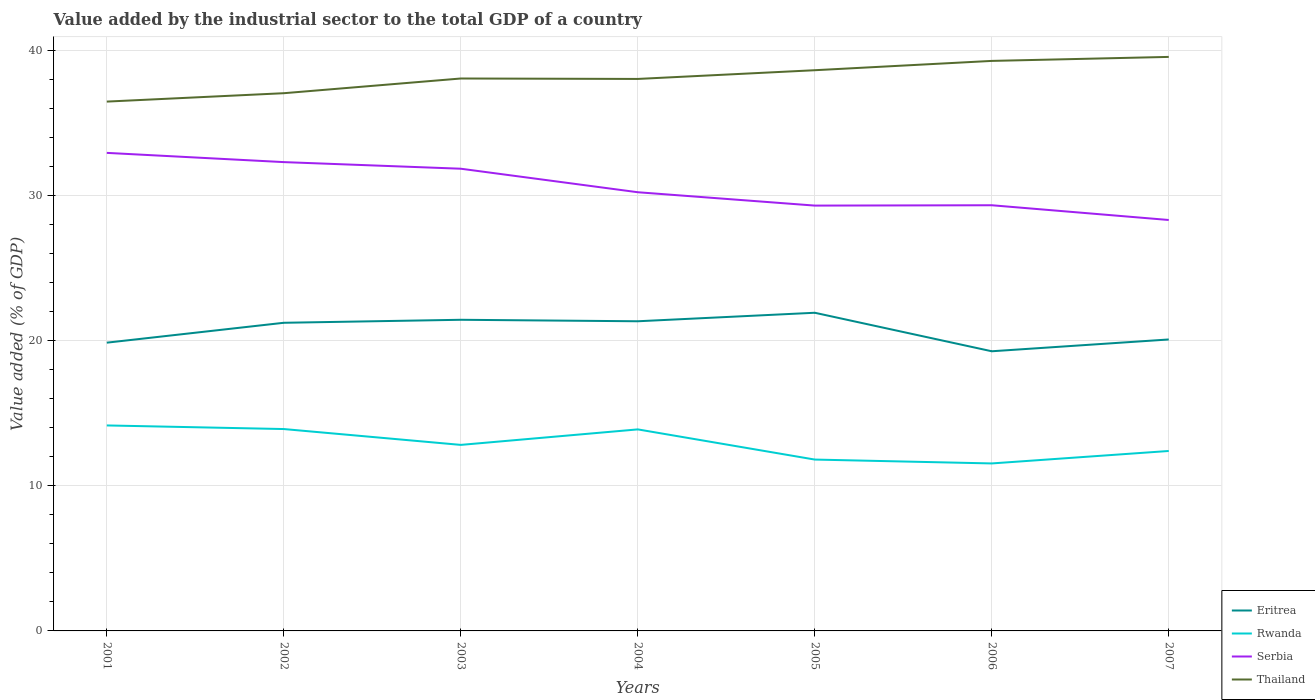Is the number of lines equal to the number of legend labels?
Offer a very short reply. Yes. Across all years, what is the maximum value added by the industrial sector to the total GDP in Eritrea?
Offer a terse response. 19.27. In which year was the value added by the industrial sector to the total GDP in Thailand maximum?
Ensure brevity in your answer.  2001. What is the total value added by the industrial sector to the total GDP in Thailand in the graph?
Your response must be concise. 0.03. What is the difference between the highest and the second highest value added by the industrial sector to the total GDP in Rwanda?
Keep it short and to the point. 2.62. What is the difference between the highest and the lowest value added by the industrial sector to the total GDP in Serbia?
Provide a succinct answer. 3. How many lines are there?
Provide a short and direct response. 4. Are the values on the major ticks of Y-axis written in scientific E-notation?
Your response must be concise. No. Does the graph contain any zero values?
Your answer should be compact. No. Where does the legend appear in the graph?
Your answer should be compact. Bottom right. How are the legend labels stacked?
Your answer should be very brief. Vertical. What is the title of the graph?
Provide a succinct answer. Value added by the industrial sector to the total GDP of a country. Does "Pakistan" appear as one of the legend labels in the graph?
Provide a short and direct response. No. What is the label or title of the X-axis?
Offer a terse response. Years. What is the label or title of the Y-axis?
Give a very brief answer. Value added (% of GDP). What is the Value added (% of GDP) of Eritrea in 2001?
Make the answer very short. 19.86. What is the Value added (% of GDP) of Rwanda in 2001?
Offer a terse response. 14.16. What is the Value added (% of GDP) of Serbia in 2001?
Provide a succinct answer. 32.93. What is the Value added (% of GDP) in Thailand in 2001?
Your answer should be compact. 36.47. What is the Value added (% of GDP) in Eritrea in 2002?
Keep it short and to the point. 21.23. What is the Value added (% of GDP) in Rwanda in 2002?
Offer a very short reply. 13.91. What is the Value added (% of GDP) of Serbia in 2002?
Offer a terse response. 32.3. What is the Value added (% of GDP) of Thailand in 2002?
Your response must be concise. 37.04. What is the Value added (% of GDP) in Eritrea in 2003?
Provide a succinct answer. 21.44. What is the Value added (% of GDP) of Rwanda in 2003?
Ensure brevity in your answer.  12.82. What is the Value added (% of GDP) in Serbia in 2003?
Keep it short and to the point. 31.84. What is the Value added (% of GDP) in Thailand in 2003?
Offer a terse response. 38.06. What is the Value added (% of GDP) in Eritrea in 2004?
Your answer should be compact. 21.33. What is the Value added (% of GDP) of Rwanda in 2004?
Provide a short and direct response. 13.88. What is the Value added (% of GDP) in Serbia in 2004?
Offer a very short reply. 30.22. What is the Value added (% of GDP) of Thailand in 2004?
Offer a very short reply. 38.03. What is the Value added (% of GDP) in Eritrea in 2005?
Make the answer very short. 21.92. What is the Value added (% of GDP) in Rwanda in 2005?
Make the answer very short. 11.81. What is the Value added (% of GDP) of Serbia in 2005?
Your answer should be compact. 29.3. What is the Value added (% of GDP) in Thailand in 2005?
Ensure brevity in your answer.  38.63. What is the Value added (% of GDP) of Eritrea in 2006?
Make the answer very short. 19.27. What is the Value added (% of GDP) of Rwanda in 2006?
Keep it short and to the point. 11.54. What is the Value added (% of GDP) of Serbia in 2006?
Your answer should be very brief. 29.33. What is the Value added (% of GDP) of Thailand in 2006?
Provide a succinct answer. 39.27. What is the Value added (% of GDP) in Eritrea in 2007?
Keep it short and to the point. 20.08. What is the Value added (% of GDP) of Rwanda in 2007?
Keep it short and to the point. 12.4. What is the Value added (% of GDP) in Serbia in 2007?
Make the answer very short. 28.31. What is the Value added (% of GDP) in Thailand in 2007?
Your answer should be compact. 39.55. Across all years, what is the maximum Value added (% of GDP) in Eritrea?
Keep it short and to the point. 21.92. Across all years, what is the maximum Value added (% of GDP) in Rwanda?
Your answer should be very brief. 14.16. Across all years, what is the maximum Value added (% of GDP) in Serbia?
Your response must be concise. 32.93. Across all years, what is the maximum Value added (% of GDP) of Thailand?
Ensure brevity in your answer.  39.55. Across all years, what is the minimum Value added (% of GDP) in Eritrea?
Your answer should be compact. 19.27. Across all years, what is the minimum Value added (% of GDP) in Rwanda?
Offer a very short reply. 11.54. Across all years, what is the minimum Value added (% of GDP) of Serbia?
Ensure brevity in your answer.  28.31. Across all years, what is the minimum Value added (% of GDP) in Thailand?
Offer a terse response. 36.47. What is the total Value added (% of GDP) of Eritrea in the graph?
Make the answer very short. 145.12. What is the total Value added (% of GDP) of Rwanda in the graph?
Provide a succinct answer. 90.51. What is the total Value added (% of GDP) in Serbia in the graph?
Give a very brief answer. 214.24. What is the total Value added (% of GDP) of Thailand in the graph?
Your answer should be compact. 267.04. What is the difference between the Value added (% of GDP) of Eritrea in 2001 and that in 2002?
Offer a terse response. -1.37. What is the difference between the Value added (% of GDP) in Rwanda in 2001 and that in 2002?
Ensure brevity in your answer.  0.25. What is the difference between the Value added (% of GDP) of Serbia in 2001 and that in 2002?
Your response must be concise. 0.64. What is the difference between the Value added (% of GDP) in Thailand in 2001 and that in 2002?
Your response must be concise. -0.58. What is the difference between the Value added (% of GDP) of Eritrea in 2001 and that in 2003?
Your answer should be compact. -1.58. What is the difference between the Value added (% of GDP) of Rwanda in 2001 and that in 2003?
Provide a succinct answer. 1.34. What is the difference between the Value added (% of GDP) in Serbia in 2001 and that in 2003?
Your answer should be compact. 1.09. What is the difference between the Value added (% of GDP) of Thailand in 2001 and that in 2003?
Your response must be concise. -1.59. What is the difference between the Value added (% of GDP) in Eritrea in 2001 and that in 2004?
Give a very brief answer. -1.47. What is the difference between the Value added (% of GDP) of Rwanda in 2001 and that in 2004?
Make the answer very short. 0.27. What is the difference between the Value added (% of GDP) in Serbia in 2001 and that in 2004?
Offer a very short reply. 2.71. What is the difference between the Value added (% of GDP) in Thailand in 2001 and that in 2004?
Your answer should be very brief. -1.56. What is the difference between the Value added (% of GDP) of Eritrea in 2001 and that in 2005?
Your answer should be very brief. -2.06. What is the difference between the Value added (% of GDP) in Rwanda in 2001 and that in 2005?
Offer a terse response. 2.35. What is the difference between the Value added (% of GDP) in Serbia in 2001 and that in 2005?
Provide a succinct answer. 3.63. What is the difference between the Value added (% of GDP) of Thailand in 2001 and that in 2005?
Give a very brief answer. -2.16. What is the difference between the Value added (% of GDP) of Eritrea in 2001 and that in 2006?
Provide a short and direct response. 0.59. What is the difference between the Value added (% of GDP) in Rwanda in 2001 and that in 2006?
Your answer should be compact. 2.62. What is the difference between the Value added (% of GDP) of Serbia in 2001 and that in 2006?
Keep it short and to the point. 3.61. What is the difference between the Value added (% of GDP) in Thailand in 2001 and that in 2006?
Offer a very short reply. -2.8. What is the difference between the Value added (% of GDP) in Eritrea in 2001 and that in 2007?
Your answer should be compact. -0.22. What is the difference between the Value added (% of GDP) of Rwanda in 2001 and that in 2007?
Your response must be concise. 1.76. What is the difference between the Value added (% of GDP) in Serbia in 2001 and that in 2007?
Your answer should be compact. 4.62. What is the difference between the Value added (% of GDP) of Thailand in 2001 and that in 2007?
Give a very brief answer. -3.08. What is the difference between the Value added (% of GDP) in Eritrea in 2002 and that in 2003?
Your answer should be compact. -0.21. What is the difference between the Value added (% of GDP) in Rwanda in 2002 and that in 2003?
Your answer should be compact. 1.09. What is the difference between the Value added (% of GDP) in Serbia in 2002 and that in 2003?
Offer a very short reply. 0.46. What is the difference between the Value added (% of GDP) of Thailand in 2002 and that in 2003?
Your answer should be compact. -1.01. What is the difference between the Value added (% of GDP) in Eritrea in 2002 and that in 2004?
Offer a terse response. -0.1. What is the difference between the Value added (% of GDP) in Rwanda in 2002 and that in 2004?
Provide a succinct answer. 0.02. What is the difference between the Value added (% of GDP) of Serbia in 2002 and that in 2004?
Your response must be concise. 2.08. What is the difference between the Value added (% of GDP) in Thailand in 2002 and that in 2004?
Provide a succinct answer. -0.98. What is the difference between the Value added (% of GDP) in Eritrea in 2002 and that in 2005?
Offer a very short reply. -0.69. What is the difference between the Value added (% of GDP) of Rwanda in 2002 and that in 2005?
Your answer should be compact. 2.1. What is the difference between the Value added (% of GDP) of Serbia in 2002 and that in 2005?
Offer a very short reply. 3. What is the difference between the Value added (% of GDP) of Thailand in 2002 and that in 2005?
Your answer should be very brief. -1.58. What is the difference between the Value added (% of GDP) in Eritrea in 2002 and that in 2006?
Offer a terse response. 1.96. What is the difference between the Value added (% of GDP) of Rwanda in 2002 and that in 2006?
Provide a short and direct response. 2.37. What is the difference between the Value added (% of GDP) in Serbia in 2002 and that in 2006?
Make the answer very short. 2.97. What is the difference between the Value added (% of GDP) in Thailand in 2002 and that in 2006?
Provide a short and direct response. -2.23. What is the difference between the Value added (% of GDP) in Eritrea in 2002 and that in 2007?
Offer a very short reply. 1.15. What is the difference between the Value added (% of GDP) in Rwanda in 2002 and that in 2007?
Your response must be concise. 1.51. What is the difference between the Value added (% of GDP) of Serbia in 2002 and that in 2007?
Provide a succinct answer. 3.99. What is the difference between the Value added (% of GDP) in Thailand in 2002 and that in 2007?
Keep it short and to the point. -2.5. What is the difference between the Value added (% of GDP) in Eritrea in 2003 and that in 2004?
Provide a succinct answer. 0.1. What is the difference between the Value added (% of GDP) of Rwanda in 2003 and that in 2004?
Give a very brief answer. -1.07. What is the difference between the Value added (% of GDP) of Serbia in 2003 and that in 2004?
Offer a very short reply. 1.62. What is the difference between the Value added (% of GDP) of Thailand in 2003 and that in 2004?
Offer a terse response. 0.03. What is the difference between the Value added (% of GDP) of Eritrea in 2003 and that in 2005?
Provide a succinct answer. -0.48. What is the difference between the Value added (% of GDP) in Rwanda in 2003 and that in 2005?
Offer a very short reply. 1.01. What is the difference between the Value added (% of GDP) in Serbia in 2003 and that in 2005?
Provide a short and direct response. 2.54. What is the difference between the Value added (% of GDP) of Thailand in 2003 and that in 2005?
Offer a very short reply. -0.57. What is the difference between the Value added (% of GDP) in Eritrea in 2003 and that in 2006?
Provide a short and direct response. 2.17. What is the difference between the Value added (% of GDP) of Rwanda in 2003 and that in 2006?
Provide a short and direct response. 1.28. What is the difference between the Value added (% of GDP) in Serbia in 2003 and that in 2006?
Your response must be concise. 2.52. What is the difference between the Value added (% of GDP) in Thailand in 2003 and that in 2006?
Ensure brevity in your answer.  -1.21. What is the difference between the Value added (% of GDP) of Eritrea in 2003 and that in 2007?
Offer a very short reply. 1.36. What is the difference between the Value added (% of GDP) of Rwanda in 2003 and that in 2007?
Offer a terse response. 0.42. What is the difference between the Value added (% of GDP) of Serbia in 2003 and that in 2007?
Your answer should be very brief. 3.53. What is the difference between the Value added (% of GDP) of Thailand in 2003 and that in 2007?
Ensure brevity in your answer.  -1.49. What is the difference between the Value added (% of GDP) in Eritrea in 2004 and that in 2005?
Give a very brief answer. -0.59. What is the difference between the Value added (% of GDP) of Rwanda in 2004 and that in 2005?
Your answer should be very brief. 2.08. What is the difference between the Value added (% of GDP) of Serbia in 2004 and that in 2005?
Your response must be concise. 0.92. What is the difference between the Value added (% of GDP) in Thailand in 2004 and that in 2005?
Make the answer very short. -0.6. What is the difference between the Value added (% of GDP) in Eritrea in 2004 and that in 2006?
Your response must be concise. 2.07. What is the difference between the Value added (% of GDP) in Rwanda in 2004 and that in 2006?
Keep it short and to the point. 2.35. What is the difference between the Value added (% of GDP) of Serbia in 2004 and that in 2006?
Your answer should be very brief. 0.9. What is the difference between the Value added (% of GDP) of Thailand in 2004 and that in 2006?
Give a very brief answer. -1.24. What is the difference between the Value added (% of GDP) of Eritrea in 2004 and that in 2007?
Make the answer very short. 1.25. What is the difference between the Value added (% of GDP) of Rwanda in 2004 and that in 2007?
Your response must be concise. 1.49. What is the difference between the Value added (% of GDP) of Serbia in 2004 and that in 2007?
Provide a succinct answer. 1.91. What is the difference between the Value added (% of GDP) of Thailand in 2004 and that in 2007?
Keep it short and to the point. -1.52. What is the difference between the Value added (% of GDP) of Eritrea in 2005 and that in 2006?
Offer a very short reply. 2.65. What is the difference between the Value added (% of GDP) in Rwanda in 2005 and that in 2006?
Your answer should be very brief. 0.27. What is the difference between the Value added (% of GDP) in Serbia in 2005 and that in 2006?
Offer a terse response. -0.02. What is the difference between the Value added (% of GDP) in Thailand in 2005 and that in 2006?
Give a very brief answer. -0.64. What is the difference between the Value added (% of GDP) in Eritrea in 2005 and that in 2007?
Give a very brief answer. 1.84. What is the difference between the Value added (% of GDP) in Rwanda in 2005 and that in 2007?
Offer a terse response. -0.59. What is the difference between the Value added (% of GDP) of Serbia in 2005 and that in 2007?
Offer a very short reply. 0.99. What is the difference between the Value added (% of GDP) of Thailand in 2005 and that in 2007?
Ensure brevity in your answer.  -0.92. What is the difference between the Value added (% of GDP) of Eritrea in 2006 and that in 2007?
Ensure brevity in your answer.  -0.81. What is the difference between the Value added (% of GDP) of Rwanda in 2006 and that in 2007?
Your answer should be very brief. -0.86. What is the difference between the Value added (% of GDP) of Serbia in 2006 and that in 2007?
Ensure brevity in your answer.  1.02. What is the difference between the Value added (% of GDP) in Thailand in 2006 and that in 2007?
Your response must be concise. -0.28. What is the difference between the Value added (% of GDP) of Eritrea in 2001 and the Value added (% of GDP) of Rwanda in 2002?
Offer a very short reply. 5.95. What is the difference between the Value added (% of GDP) in Eritrea in 2001 and the Value added (% of GDP) in Serbia in 2002?
Your response must be concise. -12.44. What is the difference between the Value added (% of GDP) in Eritrea in 2001 and the Value added (% of GDP) in Thailand in 2002?
Offer a very short reply. -17.19. What is the difference between the Value added (% of GDP) in Rwanda in 2001 and the Value added (% of GDP) in Serbia in 2002?
Give a very brief answer. -18.14. What is the difference between the Value added (% of GDP) in Rwanda in 2001 and the Value added (% of GDP) in Thailand in 2002?
Offer a very short reply. -22.89. What is the difference between the Value added (% of GDP) in Serbia in 2001 and the Value added (% of GDP) in Thailand in 2002?
Your answer should be very brief. -4.11. What is the difference between the Value added (% of GDP) of Eritrea in 2001 and the Value added (% of GDP) of Rwanda in 2003?
Your answer should be very brief. 7.04. What is the difference between the Value added (% of GDP) of Eritrea in 2001 and the Value added (% of GDP) of Serbia in 2003?
Your answer should be very brief. -11.98. What is the difference between the Value added (% of GDP) in Eritrea in 2001 and the Value added (% of GDP) in Thailand in 2003?
Keep it short and to the point. -18.2. What is the difference between the Value added (% of GDP) of Rwanda in 2001 and the Value added (% of GDP) of Serbia in 2003?
Offer a very short reply. -17.69. What is the difference between the Value added (% of GDP) of Rwanda in 2001 and the Value added (% of GDP) of Thailand in 2003?
Provide a succinct answer. -23.9. What is the difference between the Value added (% of GDP) in Serbia in 2001 and the Value added (% of GDP) in Thailand in 2003?
Your response must be concise. -5.12. What is the difference between the Value added (% of GDP) in Eritrea in 2001 and the Value added (% of GDP) in Rwanda in 2004?
Your answer should be very brief. 5.98. What is the difference between the Value added (% of GDP) of Eritrea in 2001 and the Value added (% of GDP) of Serbia in 2004?
Ensure brevity in your answer.  -10.36. What is the difference between the Value added (% of GDP) of Eritrea in 2001 and the Value added (% of GDP) of Thailand in 2004?
Your response must be concise. -18.17. What is the difference between the Value added (% of GDP) of Rwanda in 2001 and the Value added (% of GDP) of Serbia in 2004?
Your response must be concise. -16.07. What is the difference between the Value added (% of GDP) in Rwanda in 2001 and the Value added (% of GDP) in Thailand in 2004?
Offer a very short reply. -23.87. What is the difference between the Value added (% of GDP) of Serbia in 2001 and the Value added (% of GDP) of Thailand in 2004?
Your answer should be very brief. -5.09. What is the difference between the Value added (% of GDP) in Eritrea in 2001 and the Value added (% of GDP) in Rwanda in 2005?
Offer a very short reply. 8.05. What is the difference between the Value added (% of GDP) of Eritrea in 2001 and the Value added (% of GDP) of Serbia in 2005?
Provide a short and direct response. -9.44. What is the difference between the Value added (% of GDP) in Eritrea in 2001 and the Value added (% of GDP) in Thailand in 2005?
Provide a short and direct response. -18.77. What is the difference between the Value added (% of GDP) of Rwanda in 2001 and the Value added (% of GDP) of Serbia in 2005?
Provide a short and direct response. -15.15. What is the difference between the Value added (% of GDP) in Rwanda in 2001 and the Value added (% of GDP) in Thailand in 2005?
Provide a succinct answer. -24.47. What is the difference between the Value added (% of GDP) of Serbia in 2001 and the Value added (% of GDP) of Thailand in 2005?
Your answer should be very brief. -5.69. What is the difference between the Value added (% of GDP) in Eritrea in 2001 and the Value added (% of GDP) in Rwanda in 2006?
Make the answer very short. 8.32. What is the difference between the Value added (% of GDP) of Eritrea in 2001 and the Value added (% of GDP) of Serbia in 2006?
Provide a succinct answer. -9.47. What is the difference between the Value added (% of GDP) in Eritrea in 2001 and the Value added (% of GDP) in Thailand in 2006?
Provide a succinct answer. -19.41. What is the difference between the Value added (% of GDP) in Rwanda in 2001 and the Value added (% of GDP) in Serbia in 2006?
Make the answer very short. -15.17. What is the difference between the Value added (% of GDP) of Rwanda in 2001 and the Value added (% of GDP) of Thailand in 2006?
Provide a succinct answer. -25.11. What is the difference between the Value added (% of GDP) of Serbia in 2001 and the Value added (% of GDP) of Thailand in 2006?
Give a very brief answer. -6.34. What is the difference between the Value added (% of GDP) in Eritrea in 2001 and the Value added (% of GDP) in Rwanda in 2007?
Provide a succinct answer. 7.46. What is the difference between the Value added (% of GDP) of Eritrea in 2001 and the Value added (% of GDP) of Serbia in 2007?
Make the answer very short. -8.45. What is the difference between the Value added (% of GDP) of Eritrea in 2001 and the Value added (% of GDP) of Thailand in 2007?
Keep it short and to the point. -19.69. What is the difference between the Value added (% of GDP) of Rwanda in 2001 and the Value added (% of GDP) of Serbia in 2007?
Your answer should be very brief. -14.15. What is the difference between the Value added (% of GDP) of Rwanda in 2001 and the Value added (% of GDP) of Thailand in 2007?
Offer a very short reply. -25.39. What is the difference between the Value added (% of GDP) in Serbia in 2001 and the Value added (% of GDP) in Thailand in 2007?
Give a very brief answer. -6.61. What is the difference between the Value added (% of GDP) in Eritrea in 2002 and the Value added (% of GDP) in Rwanda in 2003?
Provide a short and direct response. 8.41. What is the difference between the Value added (% of GDP) in Eritrea in 2002 and the Value added (% of GDP) in Serbia in 2003?
Offer a very short reply. -10.61. What is the difference between the Value added (% of GDP) in Eritrea in 2002 and the Value added (% of GDP) in Thailand in 2003?
Make the answer very short. -16.83. What is the difference between the Value added (% of GDP) of Rwanda in 2002 and the Value added (% of GDP) of Serbia in 2003?
Your answer should be compact. -17.93. What is the difference between the Value added (% of GDP) in Rwanda in 2002 and the Value added (% of GDP) in Thailand in 2003?
Your answer should be very brief. -24.15. What is the difference between the Value added (% of GDP) of Serbia in 2002 and the Value added (% of GDP) of Thailand in 2003?
Keep it short and to the point. -5.76. What is the difference between the Value added (% of GDP) in Eritrea in 2002 and the Value added (% of GDP) in Rwanda in 2004?
Your answer should be very brief. 7.34. What is the difference between the Value added (% of GDP) in Eritrea in 2002 and the Value added (% of GDP) in Serbia in 2004?
Offer a terse response. -8.99. What is the difference between the Value added (% of GDP) of Eritrea in 2002 and the Value added (% of GDP) of Thailand in 2004?
Provide a succinct answer. -16.8. What is the difference between the Value added (% of GDP) of Rwanda in 2002 and the Value added (% of GDP) of Serbia in 2004?
Your answer should be very brief. -16.31. What is the difference between the Value added (% of GDP) of Rwanda in 2002 and the Value added (% of GDP) of Thailand in 2004?
Ensure brevity in your answer.  -24.12. What is the difference between the Value added (% of GDP) in Serbia in 2002 and the Value added (% of GDP) in Thailand in 2004?
Give a very brief answer. -5.73. What is the difference between the Value added (% of GDP) in Eritrea in 2002 and the Value added (% of GDP) in Rwanda in 2005?
Your answer should be compact. 9.42. What is the difference between the Value added (% of GDP) of Eritrea in 2002 and the Value added (% of GDP) of Serbia in 2005?
Make the answer very short. -8.07. What is the difference between the Value added (% of GDP) in Eritrea in 2002 and the Value added (% of GDP) in Thailand in 2005?
Keep it short and to the point. -17.4. What is the difference between the Value added (% of GDP) in Rwanda in 2002 and the Value added (% of GDP) in Serbia in 2005?
Offer a terse response. -15.39. What is the difference between the Value added (% of GDP) in Rwanda in 2002 and the Value added (% of GDP) in Thailand in 2005?
Provide a short and direct response. -24.72. What is the difference between the Value added (% of GDP) of Serbia in 2002 and the Value added (% of GDP) of Thailand in 2005?
Provide a succinct answer. -6.33. What is the difference between the Value added (% of GDP) of Eritrea in 2002 and the Value added (% of GDP) of Rwanda in 2006?
Your answer should be compact. 9.69. What is the difference between the Value added (% of GDP) in Eritrea in 2002 and the Value added (% of GDP) in Serbia in 2006?
Provide a short and direct response. -8.1. What is the difference between the Value added (% of GDP) of Eritrea in 2002 and the Value added (% of GDP) of Thailand in 2006?
Your response must be concise. -18.04. What is the difference between the Value added (% of GDP) in Rwanda in 2002 and the Value added (% of GDP) in Serbia in 2006?
Make the answer very short. -15.42. What is the difference between the Value added (% of GDP) in Rwanda in 2002 and the Value added (% of GDP) in Thailand in 2006?
Your response must be concise. -25.36. What is the difference between the Value added (% of GDP) in Serbia in 2002 and the Value added (% of GDP) in Thailand in 2006?
Keep it short and to the point. -6.97. What is the difference between the Value added (% of GDP) in Eritrea in 2002 and the Value added (% of GDP) in Rwanda in 2007?
Ensure brevity in your answer.  8.83. What is the difference between the Value added (% of GDP) of Eritrea in 2002 and the Value added (% of GDP) of Serbia in 2007?
Your answer should be compact. -7.08. What is the difference between the Value added (% of GDP) in Eritrea in 2002 and the Value added (% of GDP) in Thailand in 2007?
Ensure brevity in your answer.  -18.32. What is the difference between the Value added (% of GDP) in Rwanda in 2002 and the Value added (% of GDP) in Serbia in 2007?
Your response must be concise. -14.4. What is the difference between the Value added (% of GDP) in Rwanda in 2002 and the Value added (% of GDP) in Thailand in 2007?
Keep it short and to the point. -25.64. What is the difference between the Value added (% of GDP) of Serbia in 2002 and the Value added (% of GDP) of Thailand in 2007?
Your answer should be very brief. -7.25. What is the difference between the Value added (% of GDP) in Eritrea in 2003 and the Value added (% of GDP) in Rwanda in 2004?
Provide a short and direct response. 7.55. What is the difference between the Value added (% of GDP) of Eritrea in 2003 and the Value added (% of GDP) of Serbia in 2004?
Offer a very short reply. -8.79. What is the difference between the Value added (% of GDP) of Eritrea in 2003 and the Value added (% of GDP) of Thailand in 2004?
Ensure brevity in your answer.  -16.59. What is the difference between the Value added (% of GDP) in Rwanda in 2003 and the Value added (% of GDP) in Serbia in 2004?
Your answer should be very brief. -17.41. What is the difference between the Value added (% of GDP) in Rwanda in 2003 and the Value added (% of GDP) in Thailand in 2004?
Your answer should be compact. -25.21. What is the difference between the Value added (% of GDP) in Serbia in 2003 and the Value added (% of GDP) in Thailand in 2004?
Your answer should be very brief. -6.19. What is the difference between the Value added (% of GDP) in Eritrea in 2003 and the Value added (% of GDP) in Rwanda in 2005?
Provide a short and direct response. 9.63. What is the difference between the Value added (% of GDP) in Eritrea in 2003 and the Value added (% of GDP) in Serbia in 2005?
Provide a succinct answer. -7.87. What is the difference between the Value added (% of GDP) in Eritrea in 2003 and the Value added (% of GDP) in Thailand in 2005?
Give a very brief answer. -17.19. What is the difference between the Value added (% of GDP) in Rwanda in 2003 and the Value added (% of GDP) in Serbia in 2005?
Provide a short and direct response. -16.49. What is the difference between the Value added (% of GDP) of Rwanda in 2003 and the Value added (% of GDP) of Thailand in 2005?
Offer a very short reply. -25.81. What is the difference between the Value added (% of GDP) in Serbia in 2003 and the Value added (% of GDP) in Thailand in 2005?
Provide a succinct answer. -6.79. What is the difference between the Value added (% of GDP) in Eritrea in 2003 and the Value added (% of GDP) in Rwanda in 2006?
Your answer should be very brief. 9.9. What is the difference between the Value added (% of GDP) in Eritrea in 2003 and the Value added (% of GDP) in Serbia in 2006?
Give a very brief answer. -7.89. What is the difference between the Value added (% of GDP) in Eritrea in 2003 and the Value added (% of GDP) in Thailand in 2006?
Offer a terse response. -17.83. What is the difference between the Value added (% of GDP) of Rwanda in 2003 and the Value added (% of GDP) of Serbia in 2006?
Give a very brief answer. -16.51. What is the difference between the Value added (% of GDP) in Rwanda in 2003 and the Value added (% of GDP) in Thailand in 2006?
Offer a terse response. -26.45. What is the difference between the Value added (% of GDP) of Serbia in 2003 and the Value added (% of GDP) of Thailand in 2006?
Give a very brief answer. -7.43. What is the difference between the Value added (% of GDP) in Eritrea in 2003 and the Value added (% of GDP) in Rwanda in 2007?
Your answer should be very brief. 9.04. What is the difference between the Value added (% of GDP) of Eritrea in 2003 and the Value added (% of GDP) of Serbia in 2007?
Your answer should be very brief. -6.87. What is the difference between the Value added (% of GDP) in Eritrea in 2003 and the Value added (% of GDP) in Thailand in 2007?
Offer a very short reply. -18.11. What is the difference between the Value added (% of GDP) in Rwanda in 2003 and the Value added (% of GDP) in Serbia in 2007?
Offer a terse response. -15.49. What is the difference between the Value added (% of GDP) in Rwanda in 2003 and the Value added (% of GDP) in Thailand in 2007?
Make the answer very short. -26.73. What is the difference between the Value added (% of GDP) in Serbia in 2003 and the Value added (% of GDP) in Thailand in 2007?
Your answer should be compact. -7.7. What is the difference between the Value added (% of GDP) in Eritrea in 2004 and the Value added (% of GDP) in Rwanda in 2005?
Your answer should be compact. 9.53. What is the difference between the Value added (% of GDP) of Eritrea in 2004 and the Value added (% of GDP) of Serbia in 2005?
Provide a short and direct response. -7.97. What is the difference between the Value added (% of GDP) in Eritrea in 2004 and the Value added (% of GDP) in Thailand in 2005?
Keep it short and to the point. -17.3. What is the difference between the Value added (% of GDP) in Rwanda in 2004 and the Value added (% of GDP) in Serbia in 2005?
Offer a terse response. -15.42. What is the difference between the Value added (% of GDP) of Rwanda in 2004 and the Value added (% of GDP) of Thailand in 2005?
Your answer should be very brief. -24.74. What is the difference between the Value added (% of GDP) of Serbia in 2004 and the Value added (% of GDP) of Thailand in 2005?
Provide a succinct answer. -8.41. What is the difference between the Value added (% of GDP) in Eritrea in 2004 and the Value added (% of GDP) in Rwanda in 2006?
Ensure brevity in your answer.  9.79. What is the difference between the Value added (% of GDP) of Eritrea in 2004 and the Value added (% of GDP) of Serbia in 2006?
Make the answer very short. -7.99. What is the difference between the Value added (% of GDP) of Eritrea in 2004 and the Value added (% of GDP) of Thailand in 2006?
Give a very brief answer. -17.94. What is the difference between the Value added (% of GDP) of Rwanda in 2004 and the Value added (% of GDP) of Serbia in 2006?
Your answer should be compact. -15.44. What is the difference between the Value added (% of GDP) in Rwanda in 2004 and the Value added (% of GDP) in Thailand in 2006?
Keep it short and to the point. -25.39. What is the difference between the Value added (% of GDP) in Serbia in 2004 and the Value added (% of GDP) in Thailand in 2006?
Give a very brief answer. -9.05. What is the difference between the Value added (% of GDP) of Eritrea in 2004 and the Value added (% of GDP) of Rwanda in 2007?
Your answer should be compact. 8.94. What is the difference between the Value added (% of GDP) in Eritrea in 2004 and the Value added (% of GDP) in Serbia in 2007?
Make the answer very short. -6.98. What is the difference between the Value added (% of GDP) of Eritrea in 2004 and the Value added (% of GDP) of Thailand in 2007?
Offer a very short reply. -18.21. What is the difference between the Value added (% of GDP) in Rwanda in 2004 and the Value added (% of GDP) in Serbia in 2007?
Keep it short and to the point. -14.43. What is the difference between the Value added (% of GDP) in Rwanda in 2004 and the Value added (% of GDP) in Thailand in 2007?
Offer a terse response. -25.66. What is the difference between the Value added (% of GDP) of Serbia in 2004 and the Value added (% of GDP) of Thailand in 2007?
Provide a succinct answer. -9.32. What is the difference between the Value added (% of GDP) of Eritrea in 2005 and the Value added (% of GDP) of Rwanda in 2006?
Provide a short and direct response. 10.38. What is the difference between the Value added (% of GDP) in Eritrea in 2005 and the Value added (% of GDP) in Serbia in 2006?
Your response must be concise. -7.41. What is the difference between the Value added (% of GDP) in Eritrea in 2005 and the Value added (% of GDP) in Thailand in 2006?
Make the answer very short. -17.35. What is the difference between the Value added (% of GDP) in Rwanda in 2005 and the Value added (% of GDP) in Serbia in 2006?
Provide a short and direct response. -17.52. What is the difference between the Value added (% of GDP) in Rwanda in 2005 and the Value added (% of GDP) in Thailand in 2006?
Make the answer very short. -27.46. What is the difference between the Value added (% of GDP) in Serbia in 2005 and the Value added (% of GDP) in Thailand in 2006?
Give a very brief answer. -9.97. What is the difference between the Value added (% of GDP) of Eritrea in 2005 and the Value added (% of GDP) of Rwanda in 2007?
Provide a short and direct response. 9.52. What is the difference between the Value added (% of GDP) in Eritrea in 2005 and the Value added (% of GDP) in Serbia in 2007?
Your response must be concise. -6.39. What is the difference between the Value added (% of GDP) of Eritrea in 2005 and the Value added (% of GDP) of Thailand in 2007?
Offer a very short reply. -17.63. What is the difference between the Value added (% of GDP) of Rwanda in 2005 and the Value added (% of GDP) of Serbia in 2007?
Your answer should be very brief. -16.5. What is the difference between the Value added (% of GDP) in Rwanda in 2005 and the Value added (% of GDP) in Thailand in 2007?
Ensure brevity in your answer.  -27.74. What is the difference between the Value added (% of GDP) in Serbia in 2005 and the Value added (% of GDP) in Thailand in 2007?
Provide a succinct answer. -10.24. What is the difference between the Value added (% of GDP) of Eritrea in 2006 and the Value added (% of GDP) of Rwanda in 2007?
Provide a short and direct response. 6.87. What is the difference between the Value added (% of GDP) of Eritrea in 2006 and the Value added (% of GDP) of Serbia in 2007?
Provide a succinct answer. -9.04. What is the difference between the Value added (% of GDP) of Eritrea in 2006 and the Value added (% of GDP) of Thailand in 2007?
Your answer should be compact. -20.28. What is the difference between the Value added (% of GDP) in Rwanda in 2006 and the Value added (% of GDP) in Serbia in 2007?
Make the answer very short. -16.77. What is the difference between the Value added (% of GDP) of Rwanda in 2006 and the Value added (% of GDP) of Thailand in 2007?
Ensure brevity in your answer.  -28.01. What is the difference between the Value added (% of GDP) of Serbia in 2006 and the Value added (% of GDP) of Thailand in 2007?
Make the answer very short. -10.22. What is the average Value added (% of GDP) in Eritrea per year?
Offer a terse response. 20.73. What is the average Value added (% of GDP) of Rwanda per year?
Your response must be concise. 12.93. What is the average Value added (% of GDP) of Serbia per year?
Your answer should be compact. 30.61. What is the average Value added (% of GDP) in Thailand per year?
Provide a short and direct response. 38.15. In the year 2001, what is the difference between the Value added (% of GDP) of Eritrea and Value added (% of GDP) of Rwanda?
Provide a short and direct response. 5.7. In the year 2001, what is the difference between the Value added (% of GDP) of Eritrea and Value added (% of GDP) of Serbia?
Your answer should be very brief. -13.07. In the year 2001, what is the difference between the Value added (% of GDP) of Eritrea and Value added (% of GDP) of Thailand?
Offer a very short reply. -16.61. In the year 2001, what is the difference between the Value added (% of GDP) of Rwanda and Value added (% of GDP) of Serbia?
Ensure brevity in your answer.  -18.78. In the year 2001, what is the difference between the Value added (% of GDP) of Rwanda and Value added (% of GDP) of Thailand?
Provide a short and direct response. -22.31. In the year 2001, what is the difference between the Value added (% of GDP) of Serbia and Value added (% of GDP) of Thailand?
Keep it short and to the point. -3.53. In the year 2002, what is the difference between the Value added (% of GDP) in Eritrea and Value added (% of GDP) in Rwanda?
Provide a succinct answer. 7.32. In the year 2002, what is the difference between the Value added (% of GDP) of Eritrea and Value added (% of GDP) of Serbia?
Ensure brevity in your answer.  -11.07. In the year 2002, what is the difference between the Value added (% of GDP) of Eritrea and Value added (% of GDP) of Thailand?
Provide a succinct answer. -15.82. In the year 2002, what is the difference between the Value added (% of GDP) of Rwanda and Value added (% of GDP) of Serbia?
Provide a succinct answer. -18.39. In the year 2002, what is the difference between the Value added (% of GDP) in Rwanda and Value added (% of GDP) in Thailand?
Ensure brevity in your answer.  -23.14. In the year 2002, what is the difference between the Value added (% of GDP) in Serbia and Value added (% of GDP) in Thailand?
Your answer should be compact. -4.75. In the year 2003, what is the difference between the Value added (% of GDP) in Eritrea and Value added (% of GDP) in Rwanda?
Give a very brief answer. 8.62. In the year 2003, what is the difference between the Value added (% of GDP) in Eritrea and Value added (% of GDP) in Serbia?
Provide a short and direct response. -10.41. In the year 2003, what is the difference between the Value added (% of GDP) of Eritrea and Value added (% of GDP) of Thailand?
Offer a terse response. -16.62. In the year 2003, what is the difference between the Value added (% of GDP) of Rwanda and Value added (% of GDP) of Serbia?
Offer a very short reply. -19.03. In the year 2003, what is the difference between the Value added (% of GDP) in Rwanda and Value added (% of GDP) in Thailand?
Offer a terse response. -25.24. In the year 2003, what is the difference between the Value added (% of GDP) of Serbia and Value added (% of GDP) of Thailand?
Keep it short and to the point. -6.22. In the year 2004, what is the difference between the Value added (% of GDP) of Eritrea and Value added (% of GDP) of Rwanda?
Your answer should be compact. 7.45. In the year 2004, what is the difference between the Value added (% of GDP) of Eritrea and Value added (% of GDP) of Serbia?
Make the answer very short. -8.89. In the year 2004, what is the difference between the Value added (% of GDP) in Eritrea and Value added (% of GDP) in Thailand?
Offer a very short reply. -16.7. In the year 2004, what is the difference between the Value added (% of GDP) in Rwanda and Value added (% of GDP) in Serbia?
Offer a very short reply. -16.34. In the year 2004, what is the difference between the Value added (% of GDP) in Rwanda and Value added (% of GDP) in Thailand?
Your response must be concise. -24.14. In the year 2004, what is the difference between the Value added (% of GDP) in Serbia and Value added (% of GDP) in Thailand?
Provide a succinct answer. -7.81. In the year 2005, what is the difference between the Value added (% of GDP) in Eritrea and Value added (% of GDP) in Rwanda?
Offer a very short reply. 10.11. In the year 2005, what is the difference between the Value added (% of GDP) in Eritrea and Value added (% of GDP) in Serbia?
Ensure brevity in your answer.  -7.38. In the year 2005, what is the difference between the Value added (% of GDP) in Eritrea and Value added (% of GDP) in Thailand?
Offer a terse response. -16.71. In the year 2005, what is the difference between the Value added (% of GDP) in Rwanda and Value added (% of GDP) in Serbia?
Offer a terse response. -17.5. In the year 2005, what is the difference between the Value added (% of GDP) of Rwanda and Value added (% of GDP) of Thailand?
Make the answer very short. -26.82. In the year 2005, what is the difference between the Value added (% of GDP) of Serbia and Value added (% of GDP) of Thailand?
Give a very brief answer. -9.33. In the year 2006, what is the difference between the Value added (% of GDP) in Eritrea and Value added (% of GDP) in Rwanda?
Your answer should be compact. 7.73. In the year 2006, what is the difference between the Value added (% of GDP) in Eritrea and Value added (% of GDP) in Serbia?
Provide a short and direct response. -10.06. In the year 2006, what is the difference between the Value added (% of GDP) of Eritrea and Value added (% of GDP) of Thailand?
Your answer should be very brief. -20. In the year 2006, what is the difference between the Value added (% of GDP) of Rwanda and Value added (% of GDP) of Serbia?
Your response must be concise. -17.79. In the year 2006, what is the difference between the Value added (% of GDP) in Rwanda and Value added (% of GDP) in Thailand?
Give a very brief answer. -27.73. In the year 2006, what is the difference between the Value added (% of GDP) in Serbia and Value added (% of GDP) in Thailand?
Provide a short and direct response. -9.94. In the year 2007, what is the difference between the Value added (% of GDP) in Eritrea and Value added (% of GDP) in Rwanda?
Your response must be concise. 7.68. In the year 2007, what is the difference between the Value added (% of GDP) of Eritrea and Value added (% of GDP) of Serbia?
Provide a succinct answer. -8.23. In the year 2007, what is the difference between the Value added (% of GDP) of Eritrea and Value added (% of GDP) of Thailand?
Make the answer very short. -19.47. In the year 2007, what is the difference between the Value added (% of GDP) in Rwanda and Value added (% of GDP) in Serbia?
Keep it short and to the point. -15.91. In the year 2007, what is the difference between the Value added (% of GDP) in Rwanda and Value added (% of GDP) in Thailand?
Keep it short and to the point. -27.15. In the year 2007, what is the difference between the Value added (% of GDP) of Serbia and Value added (% of GDP) of Thailand?
Give a very brief answer. -11.24. What is the ratio of the Value added (% of GDP) in Eritrea in 2001 to that in 2002?
Your answer should be compact. 0.94. What is the ratio of the Value added (% of GDP) in Rwanda in 2001 to that in 2002?
Make the answer very short. 1.02. What is the ratio of the Value added (% of GDP) in Serbia in 2001 to that in 2002?
Offer a terse response. 1.02. What is the ratio of the Value added (% of GDP) in Thailand in 2001 to that in 2002?
Your answer should be compact. 0.98. What is the ratio of the Value added (% of GDP) of Eritrea in 2001 to that in 2003?
Make the answer very short. 0.93. What is the ratio of the Value added (% of GDP) in Rwanda in 2001 to that in 2003?
Provide a short and direct response. 1.1. What is the ratio of the Value added (% of GDP) in Serbia in 2001 to that in 2003?
Ensure brevity in your answer.  1.03. What is the ratio of the Value added (% of GDP) of Thailand in 2001 to that in 2003?
Your response must be concise. 0.96. What is the ratio of the Value added (% of GDP) in Eritrea in 2001 to that in 2004?
Make the answer very short. 0.93. What is the ratio of the Value added (% of GDP) in Rwanda in 2001 to that in 2004?
Make the answer very short. 1.02. What is the ratio of the Value added (% of GDP) of Serbia in 2001 to that in 2004?
Offer a very short reply. 1.09. What is the ratio of the Value added (% of GDP) in Thailand in 2001 to that in 2004?
Provide a short and direct response. 0.96. What is the ratio of the Value added (% of GDP) of Eritrea in 2001 to that in 2005?
Provide a short and direct response. 0.91. What is the ratio of the Value added (% of GDP) in Rwanda in 2001 to that in 2005?
Your answer should be compact. 1.2. What is the ratio of the Value added (% of GDP) in Serbia in 2001 to that in 2005?
Offer a very short reply. 1.12. What is the ratio of the Value added (% of GDP) of Thailand in 2001 to that in 2005?
Ensure brevity in your answer.  0.94. What is the ratio of the Value added (% of GDP) of Eritrea in 2001 to that in 2006?
Ensure brevity in your answer.  1.03. What is the ratio of the Value added (% of GDP) in Rwanda in 2001 to that in 2006?
Your answer should be compact. 1.23. What is the ratio of the Value added (% of GDP) in Serbia in 2001 to that in 2006?
Your answer should be very brief. 1.12. What is the ratio of the Value added (% of GDP) of Eritrea in 2001 to that in 2007?
Provide a succinct answer. 0.99. What is the ratio of the Value added (% of GDP) in Rwanda in 2001 to that in 2007?
Offer a very short reply. 1.14. What is the ratio of the Value added (% of GDP) of Serbia in 2001 to that in 2007?
Your response must be concise. 1.16. What is the ratio of the Value added (% of GDP) of Thailand in 2001 to that in 2007?
Give a very brief answer. 0.92. What is the ratio of the Value added (% of GDP) of Eritrea in 2002 to that in 2003?
Your answer should be compact. 0.99. What is the ratio of the Value added (% of GDP) of Rwanda in 2002 to that in 2003?
Make the answer very short. 1.09. What is the ratio of the Value added (% of GDP) of Serbia in 2002 to that in 2003?
Your answer should be compact. 1.01. What is the ratio of the Value added (% of GDP) of Thailand in 2002 to that in 2003?
Ensure brevity in your answer.  0.97. What is the ratio of the Value added (% of GDP) of Rwanda in 2002 to that in 2004?
Provide a short and direct response. 1. What is the ratio of the Value added (% of GDP) of Serbia in 2002 to that in 2004?
Your response must be concise. 1.07. What is the ratio of the Value added (% of GDP) of Thailand in 2002 to that in 2004?
Make the answer very short. 0.97. What is the ratio of the Value added (% of GDP) of Eritrea in 2002 to that in 2005?
Your answer should be very brief. 0.97. What is the ratio of the Value added (% of GDP) of Rwanda in 2002 to that in 2005?
Your answer should be compact. 1.18. What is the ratio of the Value added (% of GDP) of Serbia in 2002 to that in 2005?
Keep it short and to the point. 1.1. What is the ratio of the Value added (% of GDP) of Thailand in 2002 to that in 2005?
Make the answer very short. 0.96. What is the ratio of the Value added (% of GDP) of Eritrea in 2002 to that in 2006?
Provide a short and direct response. 1.1. What is the ratio of the Value added (% of GDP) of Rwanda in 2002 to that in 2006?
Make the answer very short. 1.21. What is the ratio of the Value added (% of GDP) of Serbia in 2002 to that in 2006?
Your answer should be very brief. 1.1. What is the ratio of the Value added (% of GDP) of Thailand in 2002 to that in 2006?
Provide a short and direct response. 0.94. What is the ratio of the Value added (% of GDP) of Eritrea in 2002 to that in 2007?
Your answer should be very brief. 1.06. What is the ratio of the Value added (% of GDP) in Rwanda in 2002 to that in 2007?
Keep it short and to the point. 1.12. What is the ratio of the Value added (% of GDP) in Serbia in 2002 to that in 2007?
Make the answer very short. 1.14. What is the ratio of the Value added (% of GDP) of Thailand in 2002 to that in 2007?
Keep it short and to the point. 0.94. What is the ratio of the Value added (% of GDP) of Eritrea in 2003 to that in 2004?
Your answer should be very brief. 1. What is the ratio of the Value added (% of GDP) in Rwanda in 2003 to that in 2004?
Provide a succinct answer. 0.92. What is the ratio of the Value added (% of GDP) in Serbia in 2003 to that in 2004?
Make the answer very short. 1.05. What is the ratio of the Value added (% of GDP) in Eritrea in 2003 to that in 2005?
Provide a succinct answer. 0.98. What is the ratio of the Value added (% of GDP) of Rwanda in 2003 to that in 2005?
Your response must be concise. 1.09. What is the ratio of the Value added (% of GDP) in Serbia in 2003 to that in 2005?
Ensure brevity in your answer.  1.09. What is the ratio of the Value added (% of GDP) of Thailand in 2003 to that in 2005?
Offer a very short reply. 0.99. What is the ratio of the Value added (% of GDP) of Eritrea in 2003 to that in 2006?
Your answer should be compact. 1.11. What is the ratio of the Value added (% of GDP) of Rwanda in 2003 to that in 2006?
Make the answer very short. 1.11. What is the ratio of the Value added (% of GDP) in Serbia in 2003 to that in 2006?
Your response must be concise. 1.09. What is the ratio of the Value added (% of GDP) in Thailand in 2003 to that in 2006?
Offer a terse response. 0.97. What is the ratio of the Value added (% of GDP) of Eritrea in 2003 to that in 2007?
Provide a succinct answer. 1.07. What is the ratio of the Value added (% of GDP) in Rwanda in 2003 to that in 2007?
Provide a short and direct response. 1.03. What is the ratio of the Value added (% of GDP) in Serbia in 2003 to that in 2007?
Keep it short and to the point. 1.12. What is the ratio of the Value added (% of GDP) of Thailand in 2003 to that in 2007?
Give a very brief answer. 0.96. What is the ratio of the Value added (% of GDP) of Eritrea in 2004 to that in 2005?
Your answer should be compact. 0.97. What is the ratio of the Value added (% of GDP) of Rwanda in 2004 to that in 2005?
Your answer should be compact. 1.18. What is the ratio of the Value added (% of GDP) in Serbia in 2004 to that in 2005?
Offer a terse response. 1.03. What is the ratio of the Value added (% of GDP) in Thailand in 2004 to that in 2005?
Your response must be concise. 0.98. What is the ratio of the Value added (% of GDP) of Eritrea in 2004 to that in 2006?
Ensure brevity in your answer.  1.11. What is the ratio of the Value added (% of GDP) of Rwanda in 2004 to that in 2006?
Make the answer very short. 1.2. What is the ratio of the Value added (% of GDP) in Serbia in 2004 to that in 2006?
Keep it short and to the point. 1.03. What is the ratio of the Value added (% of GDP) of Thailand in 2004 to that in 2006?
Offer a terse response. 0.97. What is the ratio of the Value added (% of GDP) of Eritrea in 2004 to that in 2007?
Your response must be concise. 1.06. What is the ratio of the Value added (% of GDP) in Rwanda in 2004 to that in 2007?
Your answer should be very brief. 1.12. What is the ratio of the Value added (% of GDP) of Serbia in 2004 to that in 2007?
Your response must be concise. 1.07. What is the ratio of the Value added (% of GDP) in Thailand in 2004 to that in 2007?
Provide a succinct answer. 0.96. What is the ratio of the Value added (% of GDP) of Eritrea in 2005 to that in 2006?
Offer a very short reply. 1.14. What is the ratio of the Value added (% of GDP) of Rwanda in 2005 to that in 2006?
Your answer should be compact. 1.02. What is the ratio of the Value added (% of GDP) in Serbia in 2005 to that in 2006?
Provide a succinct answer. 1. What is the ratio of the Value added (% of GDP) in Thailand in 2005 to that in 2006?
Offer a terse response. 0.98. What is the ratio of the Value added (% of GDP) in Eritrea in 2005 to that in 2007?
Offer a very short reply. 1.09. What is the ratio of the Value added (% of GDP) of Rwanda in 2005 to that in 2007?
Your answer should be compact. 0.95. What is the ratio of the Value added (% of GDP) in Serbia in 2005 to that in 2007?
Offer a terse response. 1.03. What is the ratio of the Value added (% of GDP) of Thailand in 2005 to that in 2007?
Keep it short and to the point. 0.98. What is the ratio of the Value added (% of GDP) of Eritrea in 2006 to that in 2007?
Your answer should be compact. 0.96. What is the ratio of the Value added (% of GDP) of Rwanda in 2006 to that in 2007?
Your answer should be compact. 0.93. What is the ratio of the Value added (% of GDP) in Serbia in 2006 to that in 2007?
Provide a short and direct response. 1.04. What is the ratio of the Value added (% of GDP) in Thailand in 2006 to that in 2007?
Offer a very short reply. 0.99. What is the difference between the highest and the second highest Value added (% of GDP) in Eritrea?
Your answer should be very brief. 0.48. What is the difference between the highest and the second highest Value added (% of GDP) of Rwanda?
Offer a very short reply. 0.25. What is the difference between the highest and the second highest Value added (% of GDP) in Serbia?
Your answer should be very brief. 0.64. What is the difference between the highest and the second highest Value added (% of GDP) in Thailand?
Offer a terse response. 0.28. What is the difference between the highest and the lowest Value added (% of GDP) in Eritrea?
Your response must be concise. 2.65. What is the difference between the highest and the lowest Value added (% of GDP) of Rwanda?
Keep it short and to the point. 2.62. What is the difference between the highest and the lowest Value added (% of GDP) in Serbia?
Your answer should be compact. 4.62. What is the difference between the highest and the lowest Value added (% of GDP) in Thailand?
Provide a succinct answer. 3.08. 